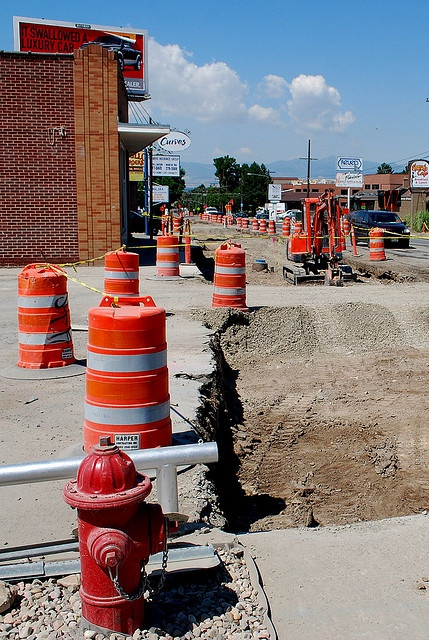Describe the objects in this image and their specific colors. I can see fire hydrant in gray, black, brown, maroon, and lightpink tones, car in gray, black, navy, and blue tones, car in gray, black, blue, and navy tones, car in gray, black, white, and teal tones, and car in gray, white, and purple tones in this image. 